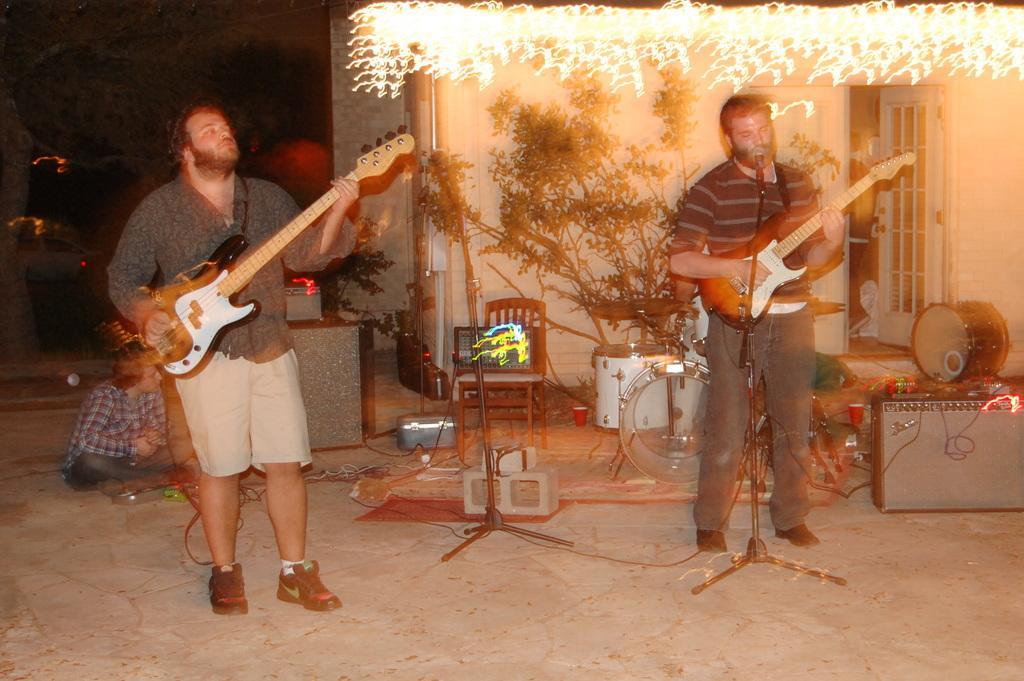How would you summarize this image in a sentence or two? In this image there are two persons who are playing musical instruments and at the background there is a plant and lights. 